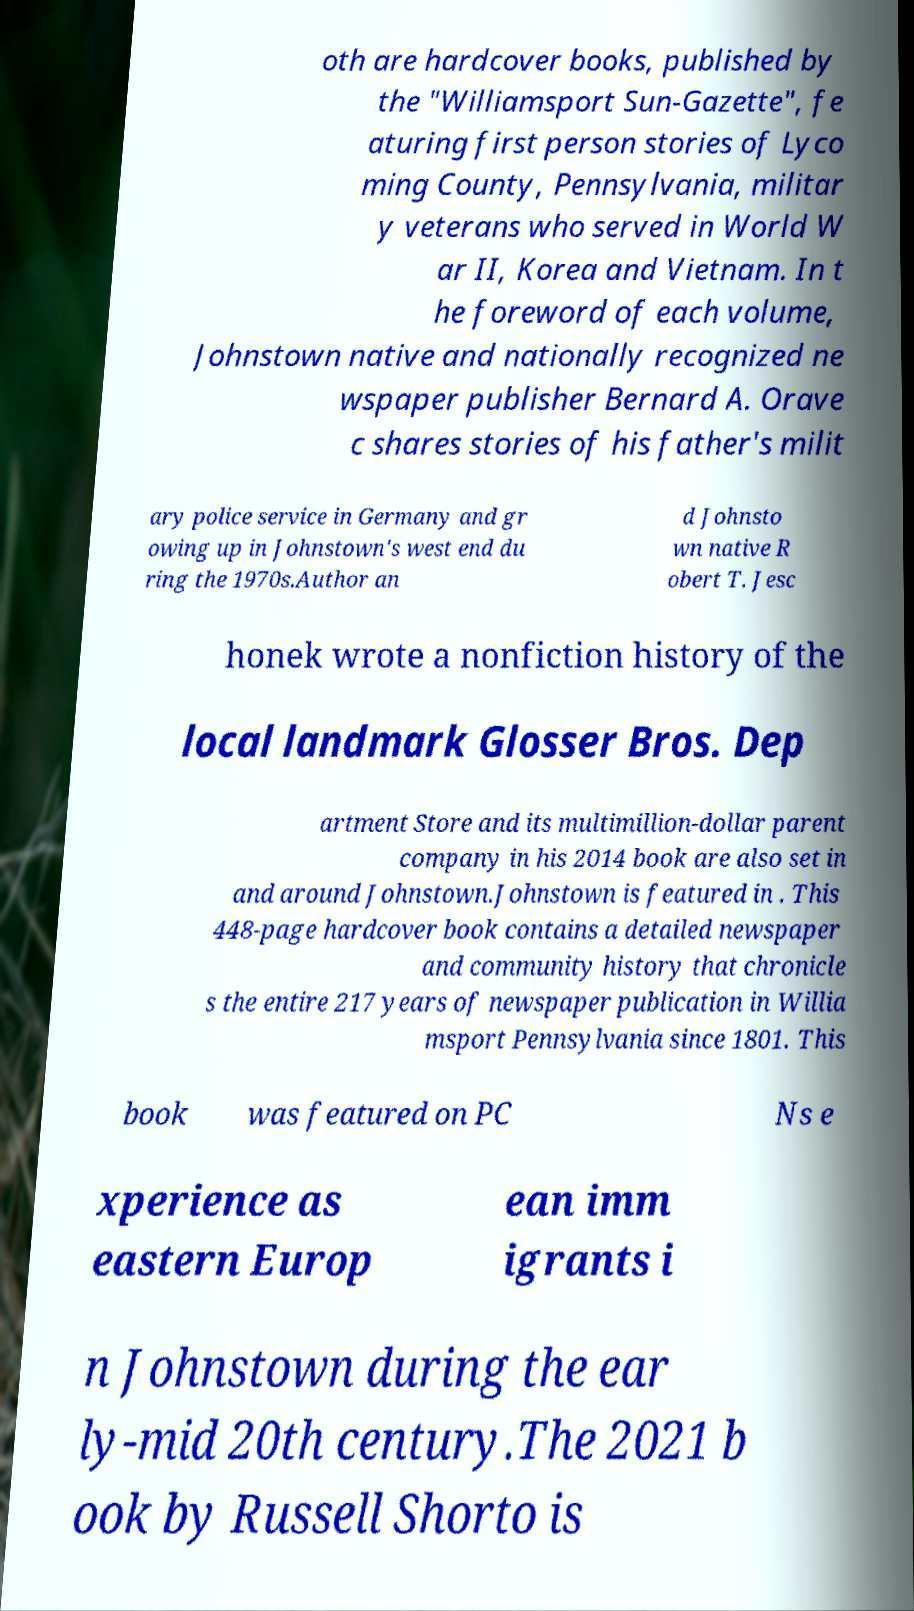Please identify and transcribe the text found in this image. oth are hardcover books, published by the "Williamsport Sun-Gazette", fe aturing first person stories of Lyco ming County, Pennsylvania, militar y veterans who served in World W ar II, Korea and Vietnam. In t he foreword of each volume, Johnstown native and nationally recognized ne wspaper publisher Bernard A. Orave c shares stories of his father's milit ary police service in Germany and gr owing up in Johnstown's west end du ring the 1970s.Author an d Johnsto wn native R obert T. Jesc honek wrote a nonfiction history of the local landmark Glosser Bros. Dep artment Store and its multimillion-dollar parent company in his 2014 book are also set in and around Johnstown.Johnstown is featured in . This 448-page hardcover book contains a detailed newspaper and community history that chronicle s the entire 217 years of newspaper publication in Willia msport Pennsylvania since 1801. This book was featured on PC Ns e xperience as eastern Europ ean imm igrants i n Johnstown during the ear ly-mid 20th century.The 2021 b ook by Russell Shorto is 